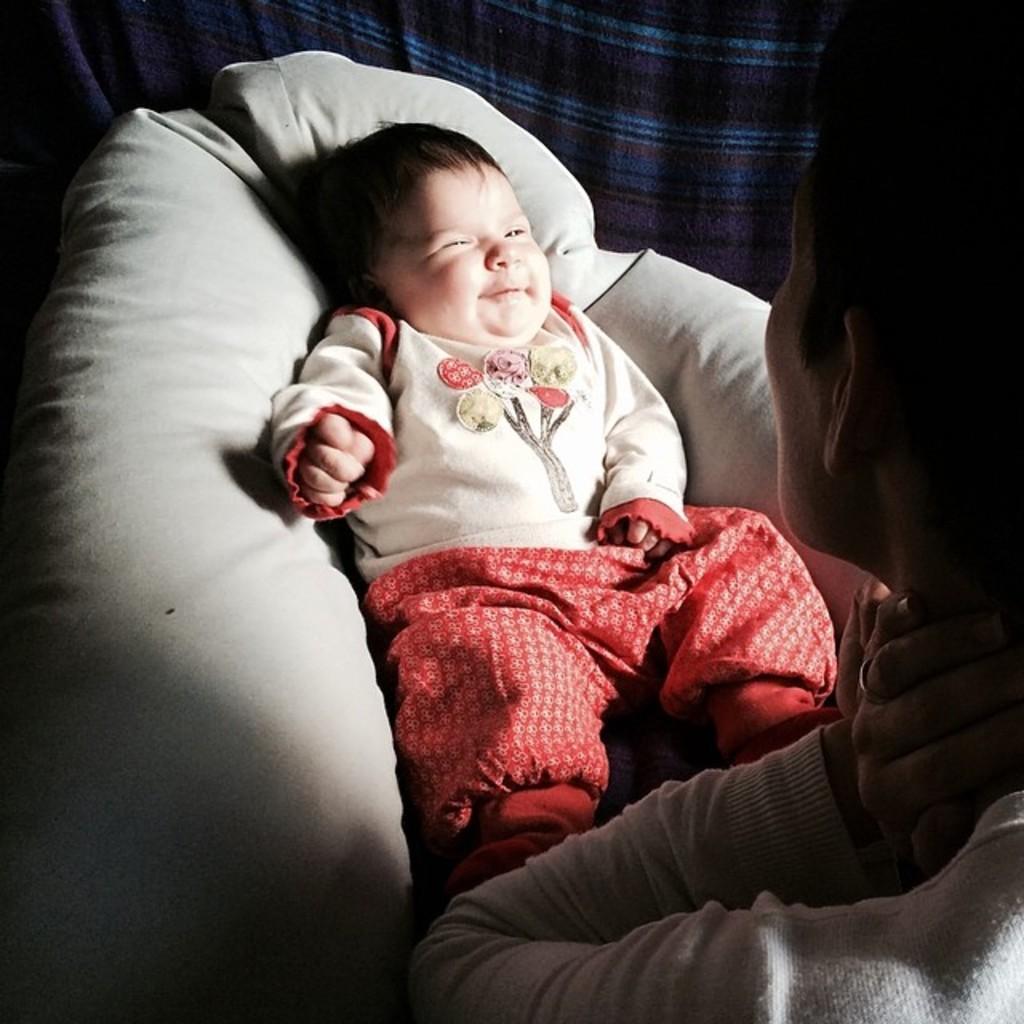How would you summarize this image in a sentence or two? In the picture we can see a man looking at a baby on the bed, in the background we can see a cloth. 